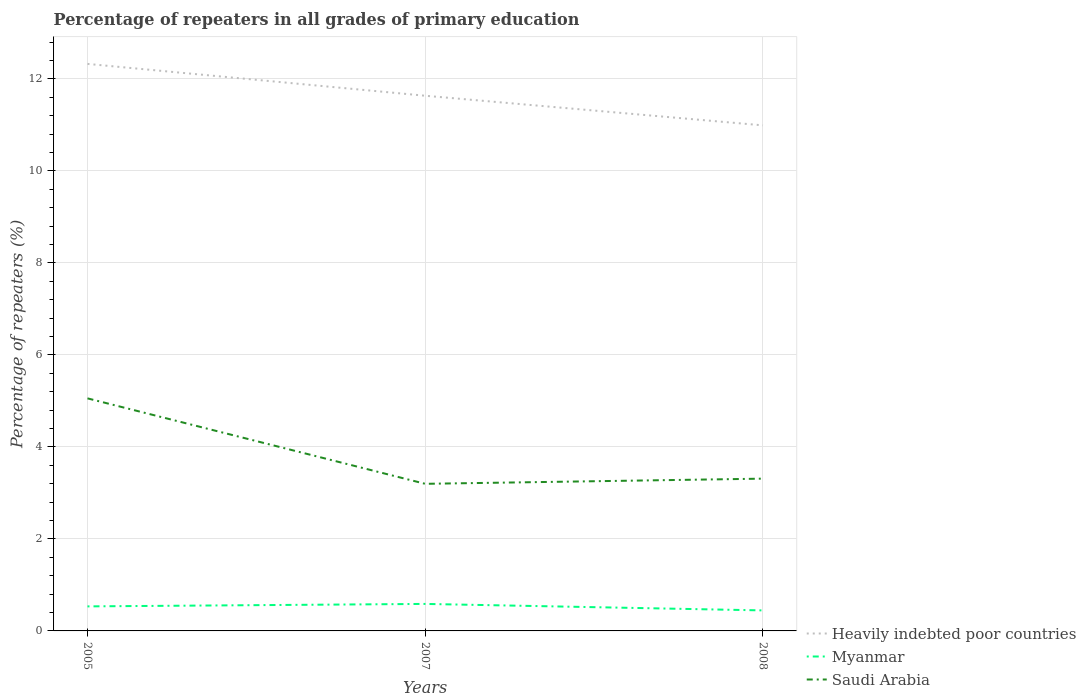How many different coloured lines are there?
Provide a short and direct response. 3. Is the number of lines equal to the number of legend labels?
Ensure brevity in your answer.  Yes. Across all years, what is the maximum percentage of repeaters in Heavily indebted poor countries?
Your answer should be very brief. 10.99. What is the total percentage of repeaters in Myanmar in the graph?
Offer a terse response. 0.14. What is the difference between the highest and the second highest percentage of repeaters in Heavily indebted poor countries?
Provide a succinct answer. 1.34. How many lines are there?
Your answer should be compact. 3. What is the title of the graph?
Offer a very short reply. Percentage of repeaters in all grades of primary education. Does "Sint Maarten (Dutch part)" appear as one of the legend labels in the graph?
Keep it short and to the point. No. What is the label or title of the Y-axis?
Offer a very short reply. Percentage of repeaters (%). What is the Percentage of repeaters (%) in Heavily indebted poor countries in 2005?
Provide a short and direct response. 12.33. What is the Percentage of repeaters (%) in Myanmar in 2005?
Your answer should be very brief. 0.53. What is the Percentage of repeaters (%) in Saudi Arabia in 2005?
Provide a short and direct response. 5.06. What is the Percentage of repeaters (%) of Heavily indebted poor countries in 2007?
Keep it short and to the point. 11.63. What is the Percentage of repeaters (%) in Myanmar in 2007?
Ensure brevity in your answer.  0.59. What is the Percentage of repeaters (%) in Saudi Arabia in 2007?
Offer a terse response. 3.2. What is the Percentage of repeaters (%) in Heavily indebted poor countries in 2008?
Provide a short and direct response. 10.99. What is the Percentage of repeaters (%) of Myanmar in 2008?
Your answer should be compact. 0.45. What is the Percentage of repeaters (%) of Saudi Arabia in 2008?
Ensure brevity in your answer.  3.31. Across all years, what is the maximum Percentage of repeaters (%) in Heavily indebted poor countries?
Your answer should be very brief. 12.33. Across all years, what is the maximum Percentage of repeaters (%) of Myanmar?
Your response must be concise. 0.59. Across all years, what is the maximum Percentage of repeaters (%) in Saudi Arabia?
Provide a short and direct response. 5.06. Across all years, what is the minimum Percentage of repeaters (%) of Heavily indebted poor countries?
Your answer should be very brief. 10.99. Across all years, what is the minimum Percentage of repeaters (%) of Myanmar?
Your answer should be very brief. 0.45. Across all years, what is the minimum Percentage of repeaters (%) of Saudi Arabia?
Provide a succinct answer. 3.2. What is the total Percentage of repeaters (%) in Heavily indebted poor countries in the graph?
Offer a terse response. 34.95. What is the total Percentage of repeaters (%) in Myanmar in the graph?
Keep it short and to the point. 1.57. What is the total Percentage of repeaters (%) of Saudi Arabia in the graph?
Make the answer very short. 11.56. What is the difference between the Percentage of repeaters (%) of Heavily indebted poor countries in 2005 and that in 2007?
Keep it short and to the point. 0.69. What is the difference between the Percentage of repeaters (%) of Myanmar in 2005 and that in 2007?
Offer a terse response. -0.05. What is the difference between the Percentage of repeaters (%) of Saudi Arabia in 2005 and that in 2007?
Offer a terse response. 1.86. What is the difference between the Percentage of repeaters (%) in Heavily indebted poor countries in 2005 and that in 2008?
Your response must be concise. 1.34. What is the difference between the Percentage of repeaters (%) of Myanmar in 2005 and that in 2008?
Your response must be concise. 0.09. What is the difference between the Percentage of repeaters (%) of Saudi Arabia in 2005 and that in 2008?
Provide a succinct answer. 1.75. What is the difference between the Percentage of repeaters (%) in Heavily indebted poor countries in 2007 and that in 2008?
Provide a succinct answer. 0.64. What is the difference between the Percentage of repeaters (%) in Myanmar in 2007 and that in 2008?
Your answer should be very brief. 0.14. What is the difference between the Percentage of repeaters (%) of Saudi Arabia in 2007 and that in 2008?
Offer a very short reply. -0.11. What is the difference between the Percentage of repeaters (%) of Heavily indebted poor countries in 2005 and the Percentage of repeaters (%) of Myanmar in 2007?
Provide a succinct answer. 11.74. What is the difference between the Percentage of repeaters (%) in Heavily indebted poor countries in 2005 and the Percentage of repeaters (%) in Saudi Arabia in 2007?
Offer a terse response. 9.13. What is the difference between the Percentage of repeaters (%) in Myanmar in 2005 and the Percentage of repeaters (%) in Saudi Arabia in 2007?
Ensure brevity in your answer.  -2.66. What is the difference between the Percentage of repeaters (%) of Heavily indebted poor countries in 2005 and the Percentage of repeaters (%) of Myanmar in 2008?
Provide a short and direct response. 11.88. What is the difference between the Percentage of repeaters (%) in Heavily indebted poor countries in 2005 and the Percentage of repeaters (%) in Saudi Arabia in 2008?
Make the answer very short. 9.02. What is the difference between the Percentage of repeaters (%) of Myanmar in 2005 and the Percentage of repeaters (%) of Saudi Arabia in 2008?
Ensure brevity in your answer.  -2.78. What is the difference between the Percentage of repeaters (%) of Heavily indebted poor countries in 2007 and the Percentage of repeaters (%) of Myanmar in 2008?
Your response must be concise. 11.19. What is the difference between the Percentage of repeaters (%) in Heavily indebted poor countries in 2007 and the Percentage of repeaters (%) in Saudi Arabia in 2008?
Your answer should be very brief. 8.32. What is the difference between the Percentage of repeaters (%) in Myanmar in 2007 and the Percentage of repeaters (%) in Saudi Arabia in 2008?
Provide a succinct answer. -2.72. What is the average Percentage of repeaters (%) of Heavily indebted poor countries per year?
Ensure brevity in your answer.  11.65. What is the average Percentage of repeaters (%) of Myanmar per year?
Make the answer very short. 0.52. What is the average Percentage of repeaters (%) in Saudi Arabia per year?
Give a very brief answer. 3.85. In the year 2005, what is the difference between the Percentage of repeaters (%) in Heavily indebted poor countries and Percentage of repeaters (%) in Myanmar?
Offer a very short reply. 11.79. In the year 2005, what is the difference between the Percentage of repeaters (%) of Heavily indebted poor countries and Percentage of repeaters (%) of Saudi Arabia?
Your answer should be compact. 7.27. In the year 2005, what is the difference between the Percentage of repeaters (%) of Myanmar and Percentage of repeaters (%) of Saudi Arabia?
Offer a terse response. -4.52. In the year 2007, what is the difference between the Percentage of repeaters (%) in Heavily indebted poor countries and Percentage of repeaters (%) in Myanmar?
Give a very brief answer. 11.05. In the year 2007, what is the difference between the Percentage of repeaters (%) of Heavily indebted poor countries and Percentage of repeaters (%) of Saudi Arabia?
Ensure brevity in your answer.  8.44. In the year 2007, what is the difference between the Percentage of repeaters (%) of Myanmar and Percentage of repeaters (%) of Saudi Arabia?
Ensure brevity in your answer.  -2.61. In the year 2008, what is the difference between the Percentage of repeaters (%) in Heavily indebted poor countries and Percentage of repeaters (%) in Myanmar?
Your answer should be compact. 10.54. In the year 2008, what is the difference between the Percentage of repeaters (%) in Heavily indebted poor countries and Percentage of repeaters (%) in Saudi Arabia?
Make the answer very short. 7.68. In the year 2008, what is the difference between the Percentage of repeaters (%) of Myanmar and Percentage of repeaters (%) of Saudi Arabia?
Make the answer very short. -2.86. What is the ratio of the Percentage of repeaters (%) of Heavily indebted poor countries in 2005 to that in 2007?
Provide a succinct answer. 1.06. What is the ratio of the Percentage of repeaters (%) of Myanmar in 2005 to that in 2007?
Your response must be concise. 0.91. What is the ratio of the Percentage of repeaters (%) of Saudi Arabia in 2005 to that in 2007?
Offer a terse response. 1.58. What is the ratio of the Percentage of repeaters (%) of Heavily indebted poor countries in 2005 to that in 2008?
Ensure brevity in your answer.  1.12. What is the ratio of the Percentage of repeaters (%) of Myanmar in 2005 to that in 2008?
Provide a succinct answer. 1.2. What is the ratio of the Percentage of repeaters (%) in Saudi Arabia in 2005 to that in 2008?
Provide a succinct answer. 1.53. What is the ratio of the Percentage of repeaters (%) in Heavily indebted poor countries in 2007 to that in 2008?
Offer a very short reply. 1.06. What is the ratio of the Percentage of repeaters (%) of Myanmar in 2007 to that in 2008?
Your answer should be compact. 1.32. What is the difference between the highest and the second highest Percentage of repeaters (%) in Heavily indebted poor countries?
Ensure brevity in your answer.  0.69. What is the difference between the highest and the second highest Percentage of repeaters (%) of Myanmar?
Give a very brief answer. 0.05. What is the difference between the highest and the second highest Percentage of repeaters (%) in Saudi Arabia?
Your answer should be compact. 1.75. What is the difference between the highest and the lowest Percentage of repeaters (%) of Heavily indebted poor countries?
Your response must be concise. 1.34. What is the difference between the highest and the lowest Percentage of repeaters (%) in Myanmar?
Your answer should be very brief. 0.14. What is the difference between the highest and the lowest Percentage of repeaters (%) of Saudi Arabia?
Make the answer very short. 1.86. 